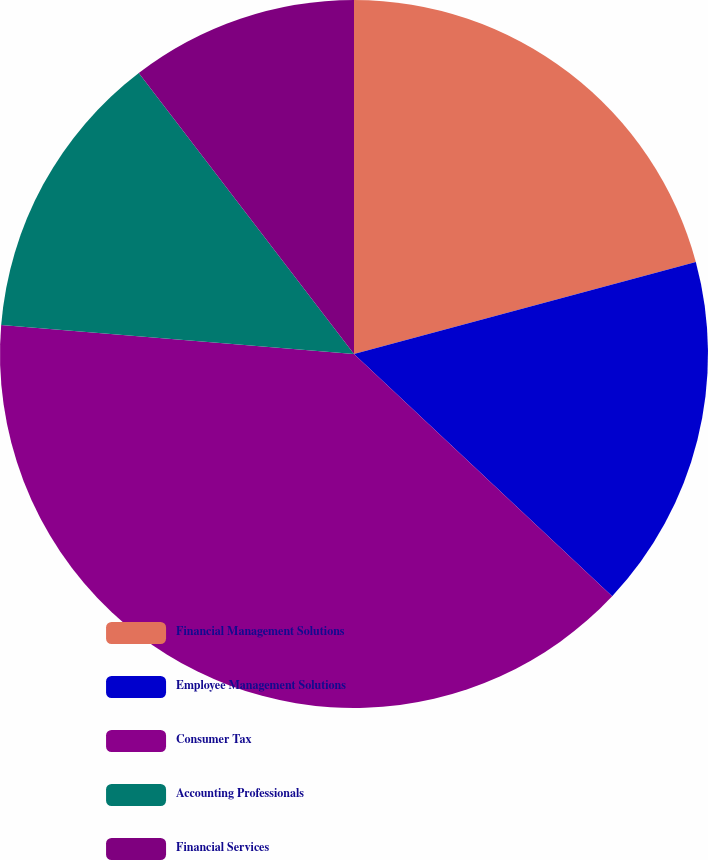<chart> <loc_0><loc_0><loc_500><loc_500><pie_chart><fcel>Financial Management Solutions<fcel>Employee Management Solutions<fcel>Consumer Tax<fcel>Accounting Professionals<fcel>Financial Services<nl><fcel>20.81%<fcel>16.18%<fcel>39.31%<fcel>13.29%<fcel>10.4%<nl></chart> 